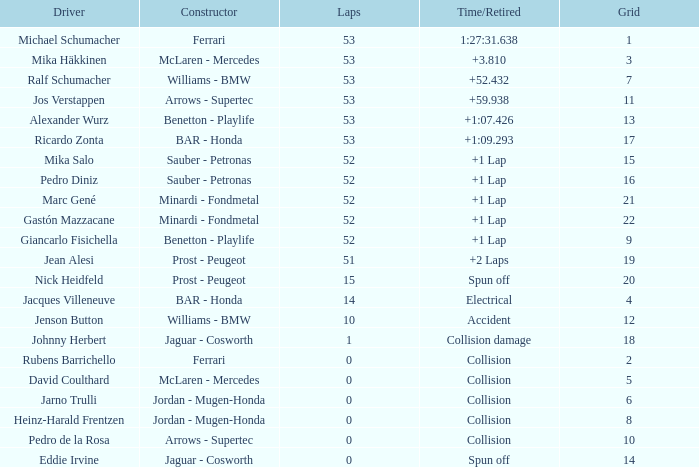What is the median laps for a grid smaller than 17, and a constructor of williams - bmw, operated by jenson button? 10.0. 